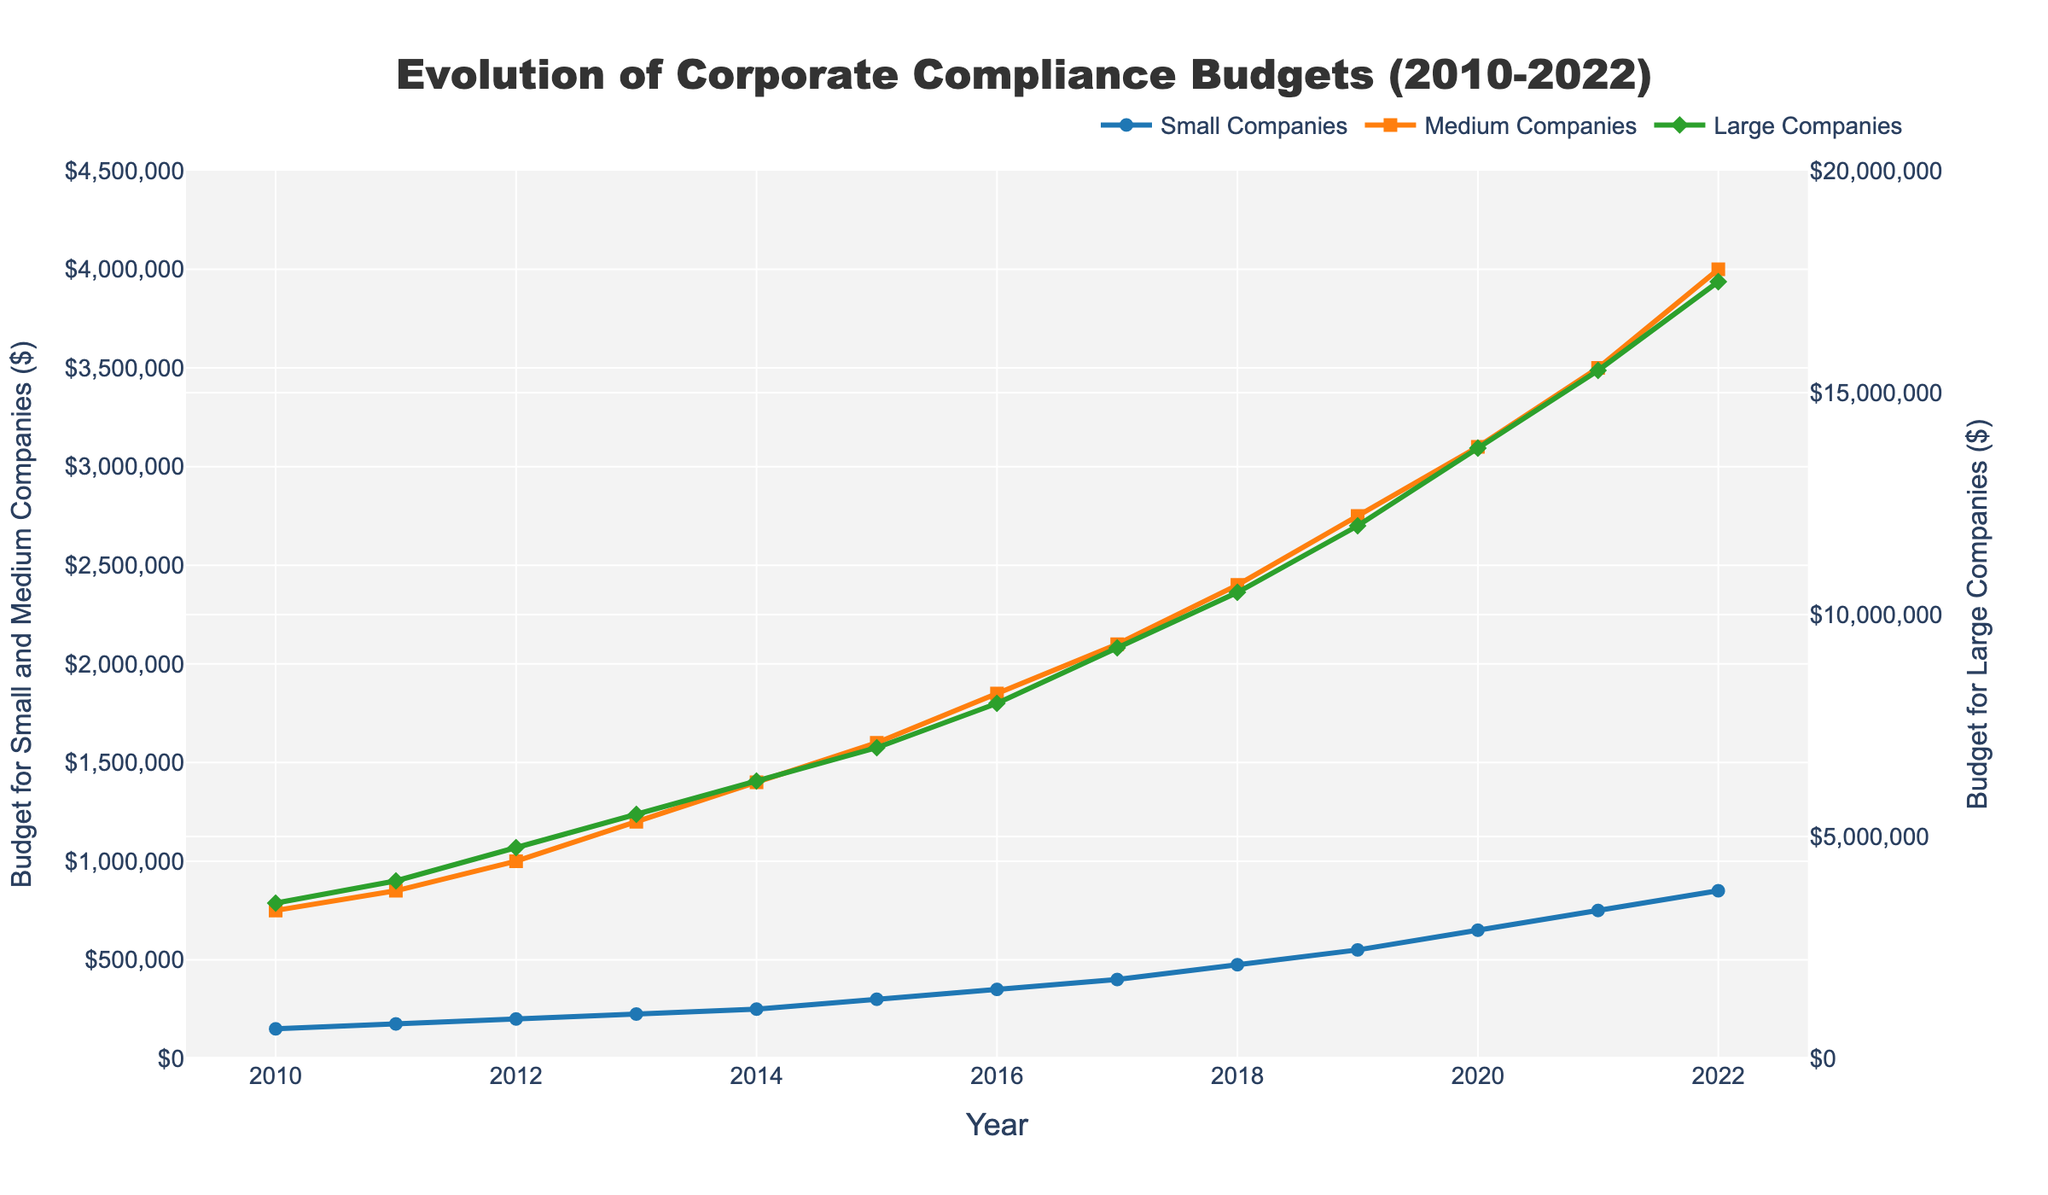Which company category had the highest compliance budget in 2022? Large Companies had the highest compliance budget in 2022 as indicated by the green line at approximately $17,500,000.
Answer: Large Companies How much did the compliance budget for Medium Companies increase from 2010 to 2022? The compliance budget for Medium Companies increased from $750,000 in 2010 to $4,000,000 in 2022. The increase is $4,000,000 - $750,000 = $3,250,000.
Answer: $3,250,000 Between which years did Large Companies see the highest increase in their compliance budget? The largest increase can be observed between 2010 and 2022, with the budget growing from $3,500,000 to $17,500,000, but the highest annual increase occurred between 2019 and 2020 where the budget increased from $12,000,000 to $13,750,000, a $1,750,000 increase in one year.
Answer: 2019 and 2020 What is the average compliance budget for Small Companies over the years shown? To determine the average, sum the budgets from all years and then divide by the number of years. Sum = $150,000 + $175,000 + $200,000 + $225,000 + $250,000 + $300,000 + $350,000 + $400,000 + $475,000 + $550,000 + $650,000 + $750,000 + $850,000 = $5,325,000. There are 13 years, so average = $5,325,000 / 13 ≈ $409,615.38.
Answer: $409,615.38 In what year did Medium Companies have a compliance budget of $2,100,000? Medium Companies had a compliance budget of $2,100,000 in the year 2017, as indicated by the orange line with a square marker.
Answer: 2017 Which company category showed a steady increase in compliance budgets every year? All three categories—Small, Medium, and Large Companies—show a steady increase in their compliance budgets each year, as all lines continuously rise without any dips.
Answer: All Companies Which company category's compliance budget doubled first from its 2010 value? Small Companies' compliance budget doubled first from $150,000 in 2010 to approximately $300,000 in 2015. Medium Companies doubled from $750,000 in 2010 to $1,500,000 in 2015, and Large Companies doubled from $3,500,000 in 2010 to roughly $7,000,000 in 2015.
Answer: Small Companies What is the difference in compliance budgets between Small and Large Companies in 2020? In 2020, the compliance budget for Small Companies was $650,000 and for Large Companies was $13,750,000. The difference is $13,750,000 - $650,000 = $13,100,000.
Answer: $13,100,000 